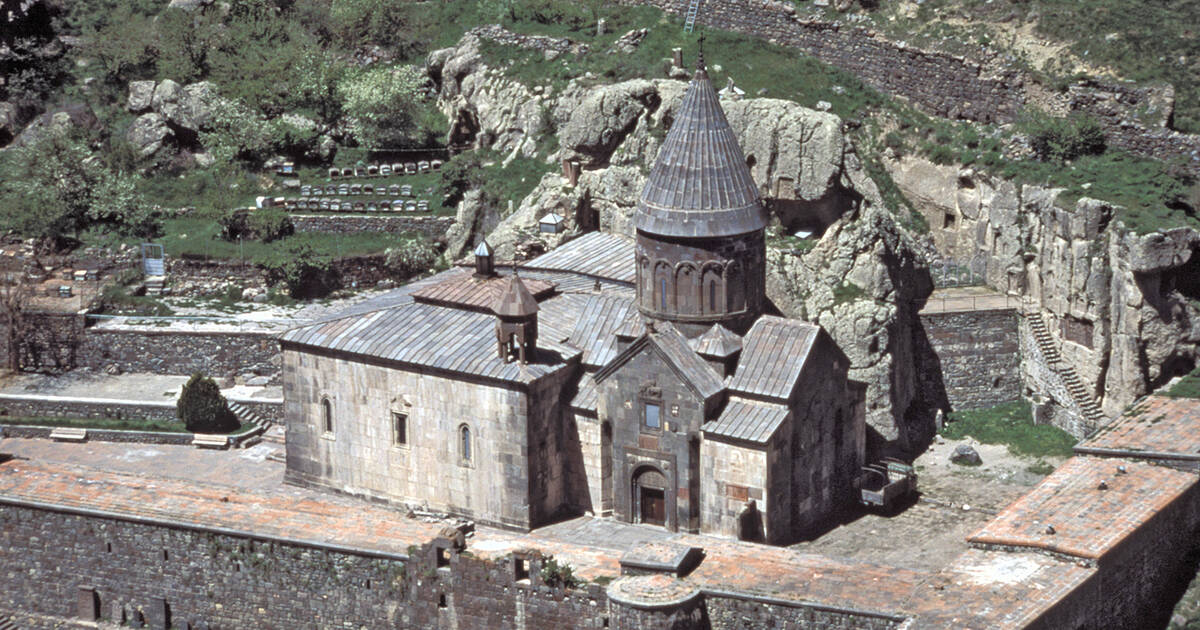How does the natural landscape integrate with the architecture of the monastery? The natural landscape is seamlessly integrated into the architecture of the Geghard Monastery. The builders utilized the natural contours of the rocky cliffs to carve the monastery directly into the stone, creating a unified appearance between man-made structures and natural formations. This not only provided natural defense but also emphasized a spiritual connection to the landscape, as if the monastery is emerging from the earth itself. The surrounding greenery and the rugged stone backdrop provide a stark but harmonious contrast, exemplifying a perfect blend of natural beauty and human ingenuity. 